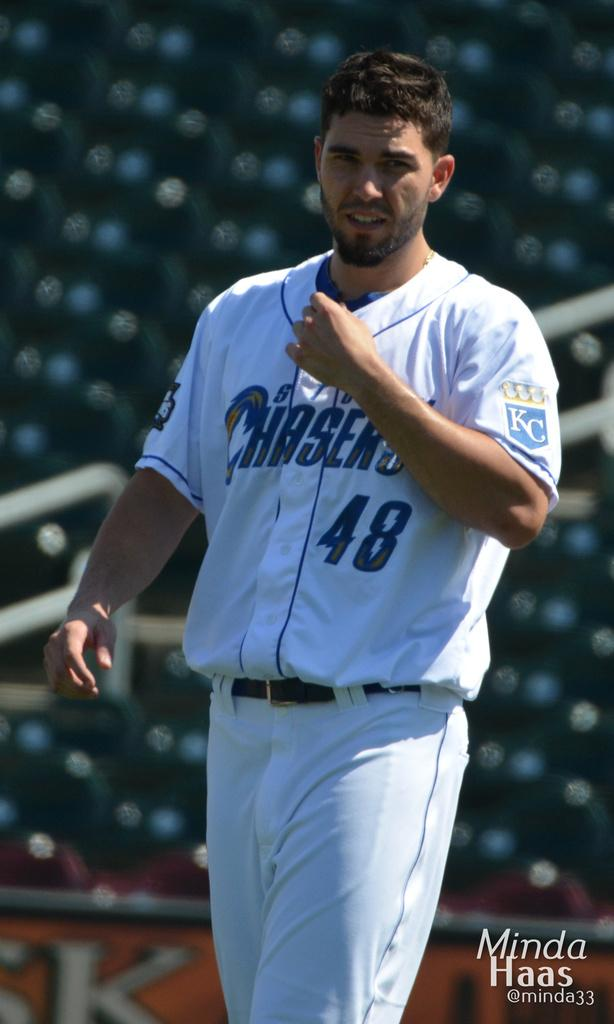<image>
Give a short and clear explanation of the subsequent image. A man has the number 48 in blue on his shirt 